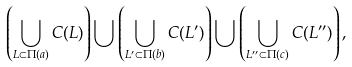Convert formula to latex. <formula><loc_0><loc_0><loc_500><loc_500>\left ( \bigcup _ { L \subset \Pi ( a ) } C ( L ) \right ) \bigcup \left ( \bigcup _ { L ^ { \prime } \subset \Pi ( b ) } C ( L ^ { \prime } ) \right ) \bigcup \left ( \bigcup _ { L ^ { \prime \prime } \subset \Pi ( c ) } C ( L ^ { \prime \prime } ) \right ) ,</formula> 